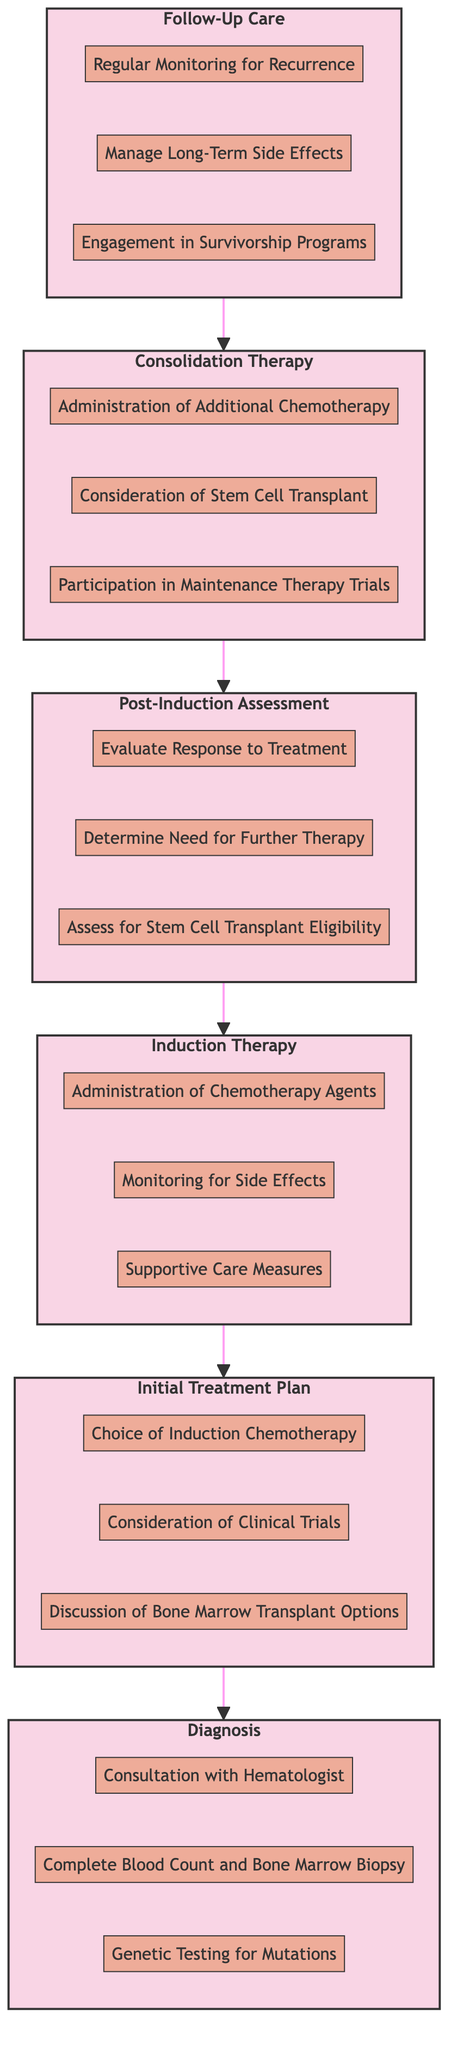What is the first stage in the treatment journey? The first stage in the treatment journey for AML is depicted at the bottom of the flowchart. Tracing the flow upward, the initial node is labeled "Diagnosis."
Answer: Diagnosis How many decisions are listed under Post-Induction Assessment? Observing the "Post-Induction Assessment" stage, there are three decisions listed beneath this stage: "Evaluate Response to Treatment," "Determine Need for Further Therapy," and "Assess for Stem Cell Transplant Eligibility." This gives a total of three decisions.
Answer: 3 Which stage follows Induction Therapy? Flipping through the sequence, the stage that comes directly after "Induction Therapy" in the flow is "Post-Induction Assessment." This is determined by the direction of the arrows indicating the flow of the treatment journey.
Answer: Post-Induction Assessment What is the last stage in the treatment journey? Reviewing the main path of the flowchart, the last stage that appears at the top is "Follow-Up Care," which concludes the treatment journey.
Answer: Follow-Up Care How many total stages are in the treatment journey flowchart? By counting the main stages labeled in the flowchart, there are a total of six distinct stages: "Diagnosis," "Initial Treatment Plan," "Induction Therapy," "Post-Induction Assessment," "Consolidation Therapy," and "Follow-Up Care."
Answer: 6 Which decision comes after the Administration of Chemotherapy Agents? Looking at the "Induction Therapy" section in the flowchart, the decision that follows "Administration of Chemotherapy Agents" is "Monitoring for Side Effects." The sequential structure of the diagram reveals this order.
Answer: Monitoring for Side Effects What type of clinical follow-up is suggested at the Follow-Up Care stage? Examining the decisions in the "Follow-Up Care" stage, one suggested clinical follow-up is "Regular Monitoring for Recurrence," indicating the ongoing assessments after initial treatment.
Answer: Regular Monitoring for Recurrence What decisions are involved in the Consolidation Therapy stage? In the "Consolidation Therapy" section, three decisions are listed: "Administration of Additional Chemotherapy," "Consideration of Stem Cell Transplant," and "Participation in Maintenance Therapy Trials." This outlines the treatment options available at that stage.
Answer: Administration of Additional Chemotherapy, Consideration of Stem Cell Transplant, Participation in Maintenance Therapy Trials Which stage allows for consideration of Clinical Trials? The "Initial Treatment Plan" stage includes the decision "Consideration of Clinical Trials," indicating this is when options like trials may be discussed as part of the treatment approach.
Answer: Initial Treatment Plan 